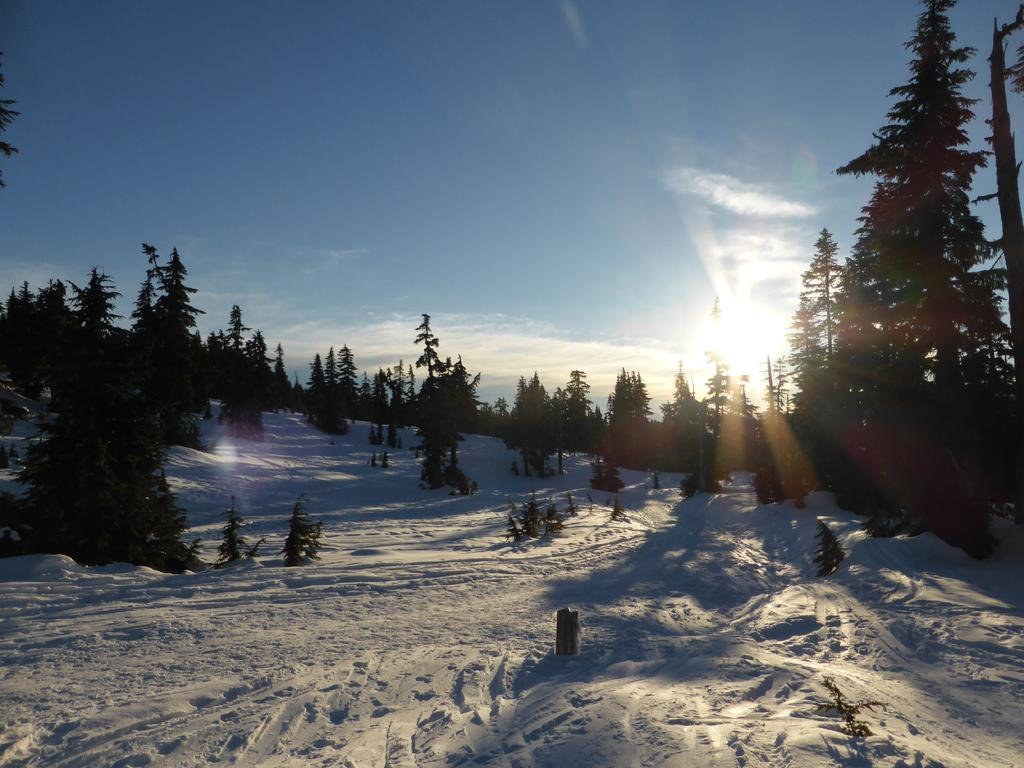What type of vegetation can be seen in the image? There are many trees in the image. What celestial body is visible in the sky? There is a sun in the sky. How would you describe the sky in the image? The sky is blue and slightly cloudy. What weather condition might be suggested by the presence of snow in the image? The presence of snow suggests a cold or wintry weather condition. What color is the hen that is painting a truck in the image? There is no hen or truck present in the image; it features trees, a sun, a blue and slightly cloudy sky, and snow. 